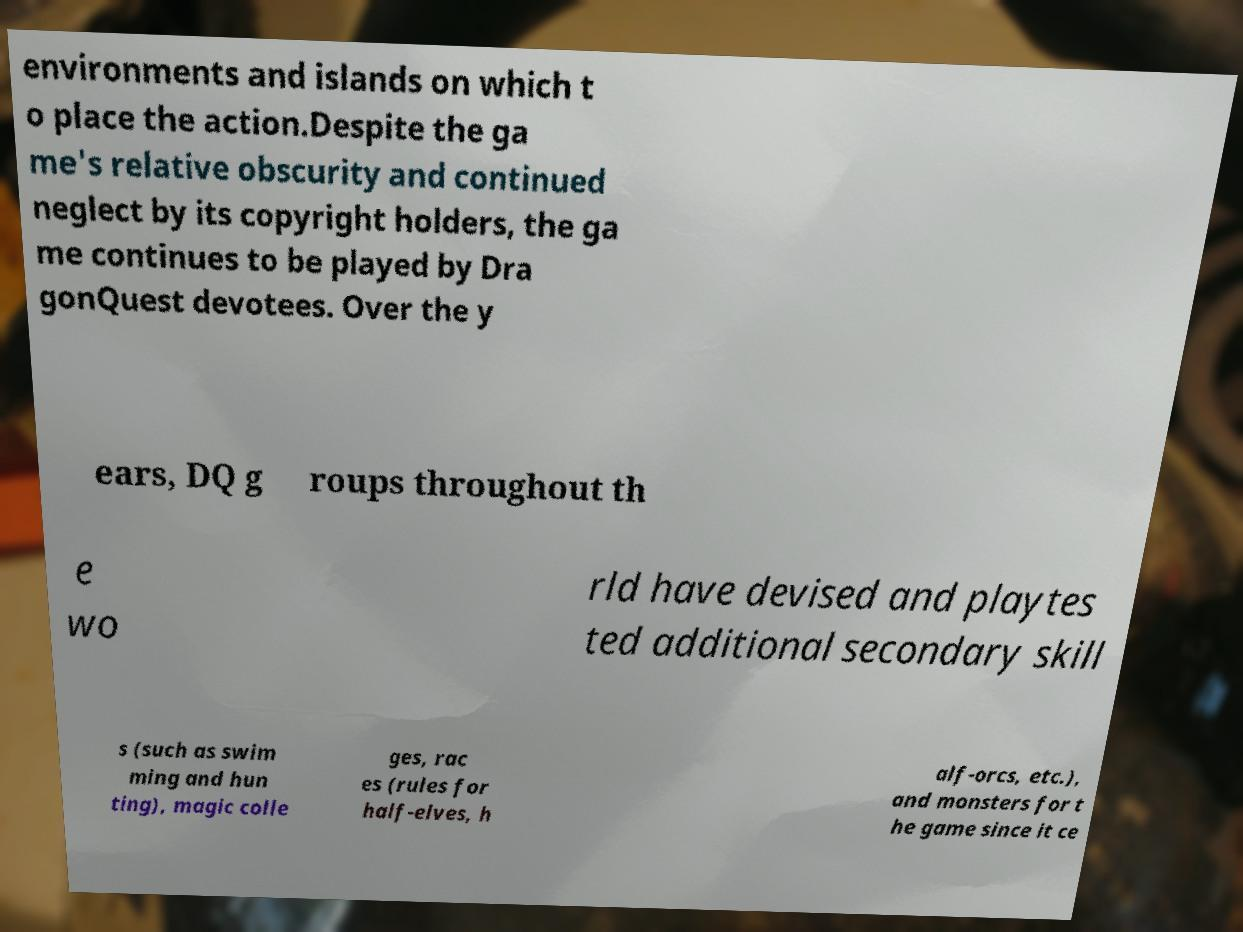I need the written content from this picture converted into text. Can you do that? environments and islands on which t o place the action.Despite the ga me's relative obscurity and continued neglect by its copyright holders, the ga me continues to be played by Dra gonQuest devotees. Over the y ears, DQ g roups throughout th e wo rld have devised and playtes ted additional secondary skill s (such as swim ming and hun ting), magic colle ges, rac es (rules for half-elves, h alf-orcs, etc.), and monsters for t he game since it ce 